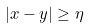Convert formula to latex. <formula><loc_0><loc_0><loc_500><loc_500>| x - y | \geq \eta</formula> 